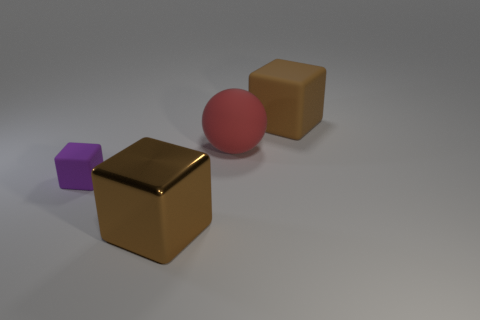Add 4 tiny spheres. How many objects exist? 8 Subtract all blocks. How many objects are left? 1 Subtract all large brown metallic cubes. Subtract all big metal objects. How many objects are left? 2 Add 3 tiny purple objects. How many tiny purple objects are left? 4 Add 2 big matte blocks. How many big matte blocks exist? 3 Subtract 0 purple cylinders. How many objects are left? 4 